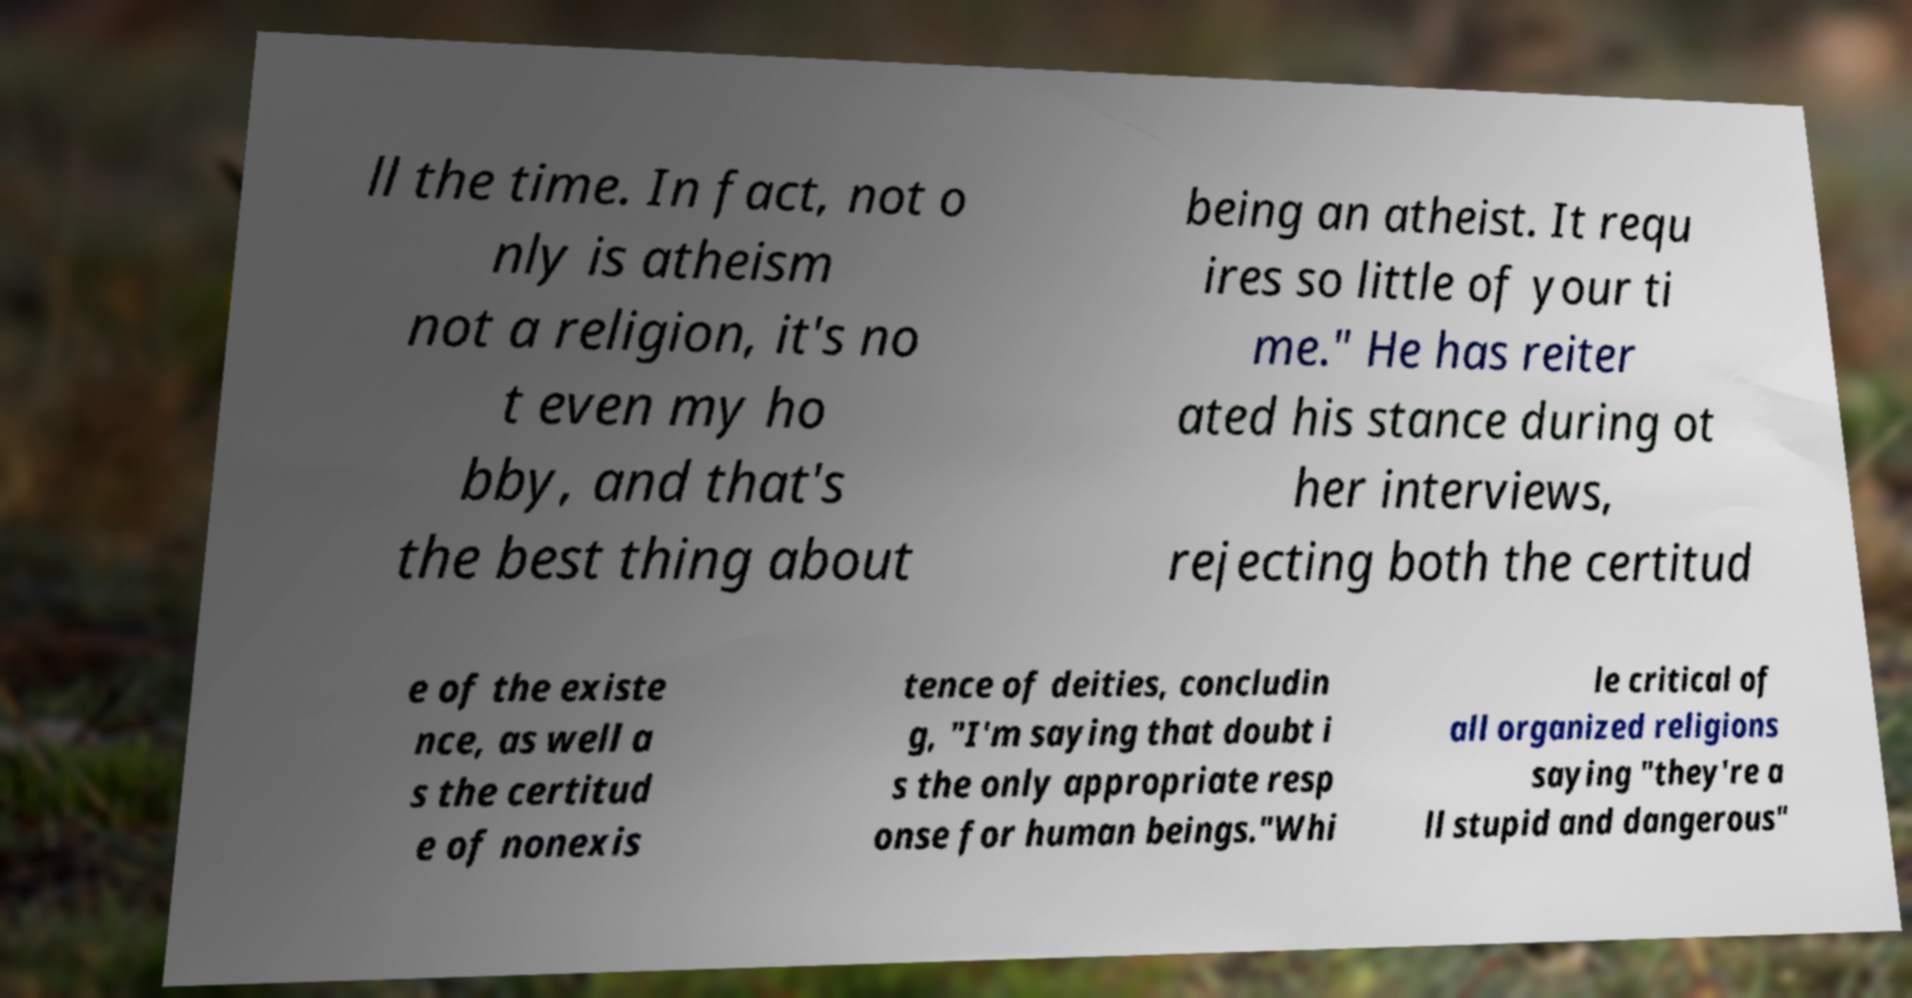What messages or text are displayed in this image? I need them in a readable, typed format. ll the time. In fact, not o nly is atheism not a religion, it's no t even my ho bby, and that's the best thing about being an atheist. It requ ires so little of your ti me." He has reiter ated his stance during ot her interviews, rejecting both the certitud e of the existe nce, as well a s the certitud e of nonexis tence of deities, concludin g, "I'm saying that doubt i s the only appropriate resp onse for human beings."Whi le critical of all organized religions saying "they're a ll stupid and dangerous" 